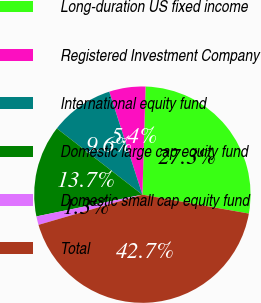Convert chart to OTSL. <chart><loc_0><loc_0><loc_500><loc_500><pie_chart><fcel>Long-duration US fixed income<fcel>Registered Investment Company<fcel>International equity fund<fcel>Domestic large cap equity fund<fcel>Domestic small cap equity fund<fcel>Total<nl><fcel>27.33%<fcel>5.42%<fcel>9.56%<fcel>13.71%<fcel>1.28%<fcel>42.7%<nl></chart> 